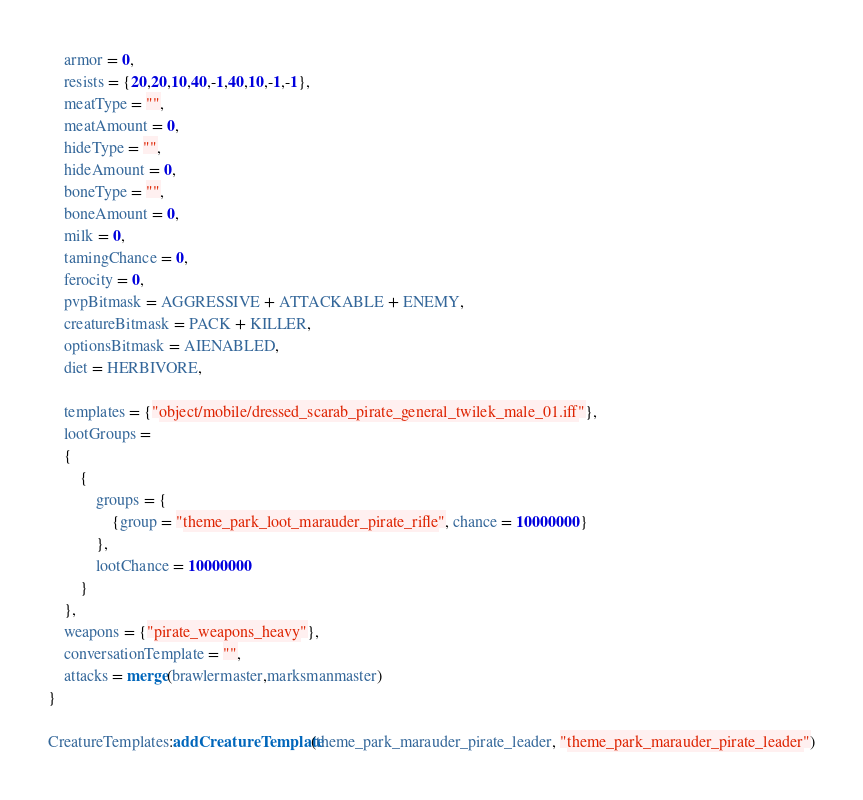<code> <loc_0><loc_0><loc_500><loc_500><_Lua_>	armor = 0,
	resists = {20,20,10,40,-1,40,10,-1,-1},
	meatType = "",
	meatAmount = 0,
	hideType = "",
	hideAmount = 0,
	boneType = "",
	boneAmount = 0,
	milk = 0,
	tamingChance = 0,
	ferocity = 0,
	pvpBitmask = AGGRESSIVE + ATTACKABLE + ENEMY,
	creatureBitmask = PACK + KILLER,
	optionsBitmask = AIENABLED,
	diet = HERBIVORE,

	templates = {"object/mobile/dressed_scarab_pirate_general_twilek_male_01.iff"},
	lootGroups =
	{
		{
			groups = {
				{group = "theme_park_loot_marauder_pirate_rifle", chance = 10000000}
			},
			lootChance = 10000000
		}
	},
	weapons = {"pirate_weapons_heavy"},
	conversationTemplate = "",
	attacks = merge(brawlermaster,marksmanmaster)
}

CreatureTemplates:addCreatureTemplate(theme_park_marauder_pirate_leader, "theme_park_marauder_pirate_leader")
</code> 